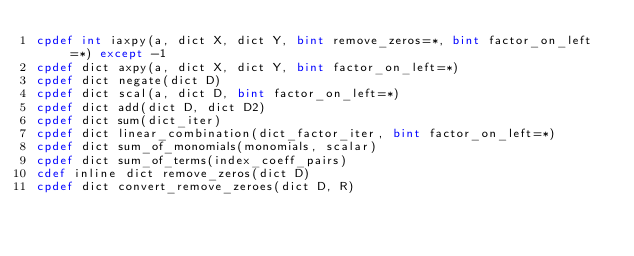<code> <loc_0><loc_0><loc_500><loc_500><_Cython_>cpdef int iaxpy(a, dict X, dict Y, bint remove_zeros=*, bint factor_on_left=*) except -1
cpdef dict axpy(a, dict X, dict Y, bint factor_on_left=*)
cpdef dict negate(dict D)
cpdef dict scal(a, dict D, bint factor_on_left=*)
cpdef dict add(dict D, dict D2)
cpdef dict sum(dict_iter)
cpdef dict linear_combination(dict_factor_iter, bint factor_on_left=*)
cpdef dict sum_of_monomials(monomials, scalar)
cpdef dict sum_of_terms(index_coeff_pairs)
cdef inline dict remove_zeros(dict D)
cpdef dict convert_remove_zeroes(dict D, R)

</code> 